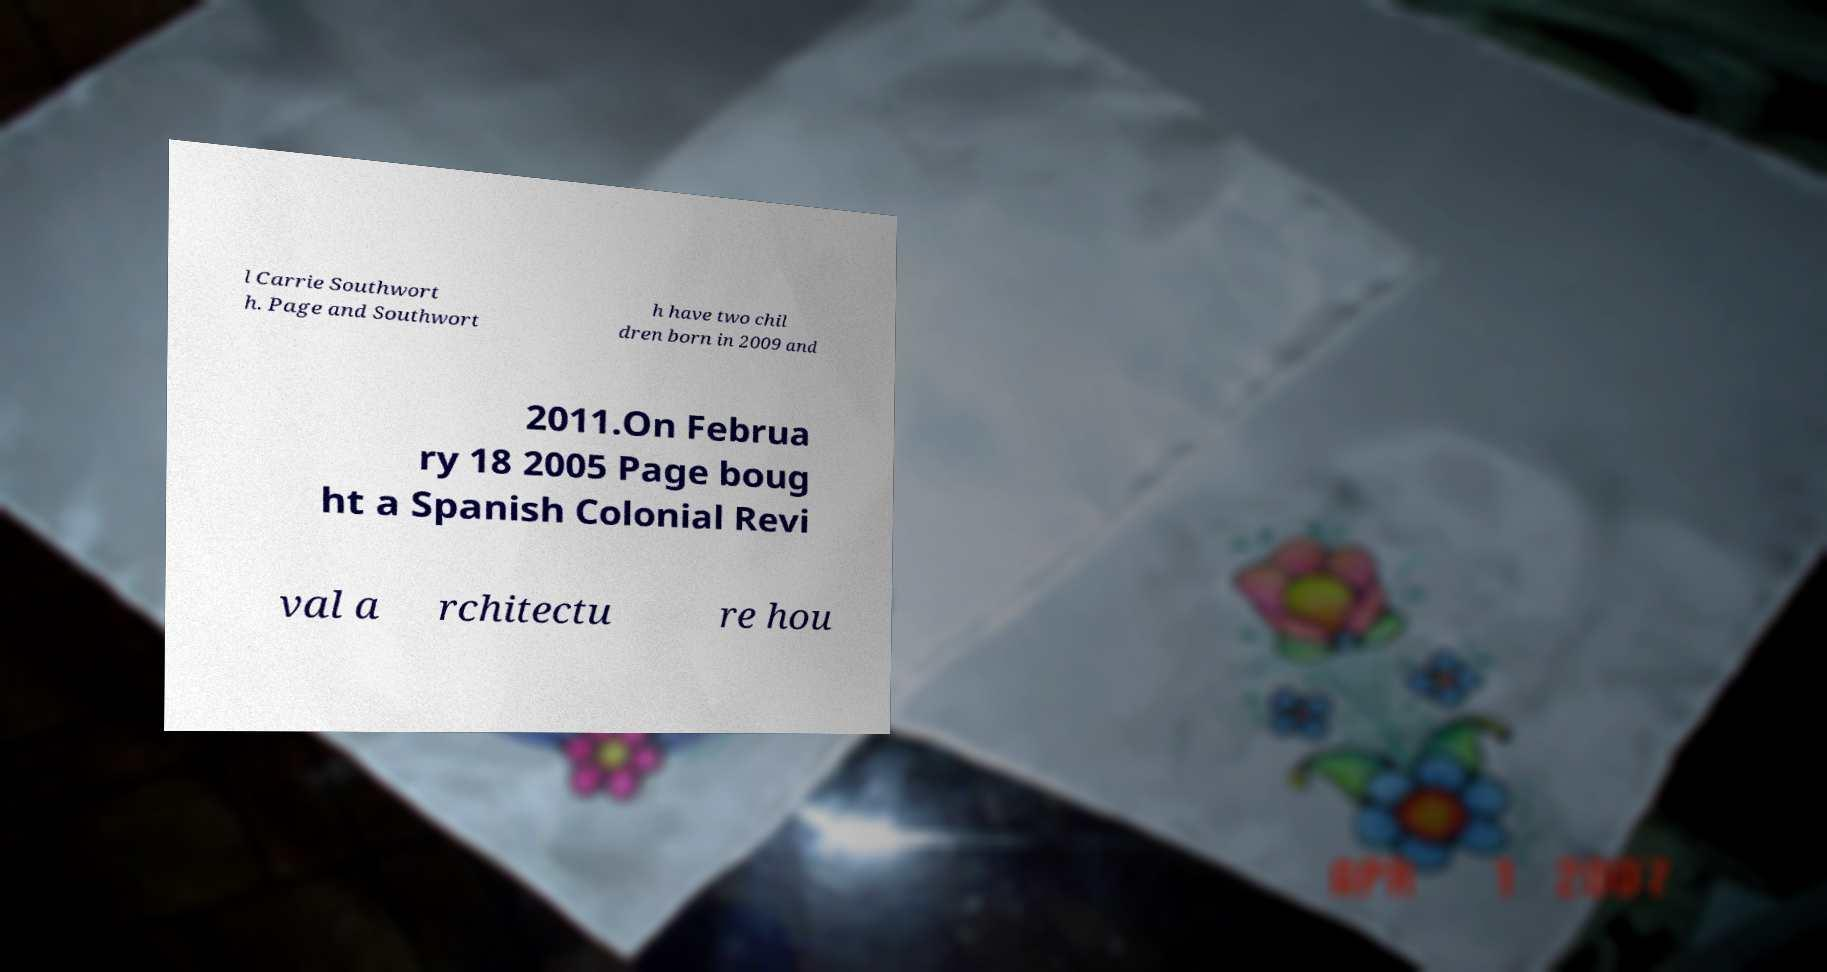Can you read and provide the text displayed in the image?This photo seems to have some interesting text. Can you extract and type it out for me? l Carrie Southwort h. Page and Southwort h have two chil dren born in 2009 and 2011.On Februa ry 18 2005 Page boug ht a Spanish Colonial Revi val a rchitectu re hou 